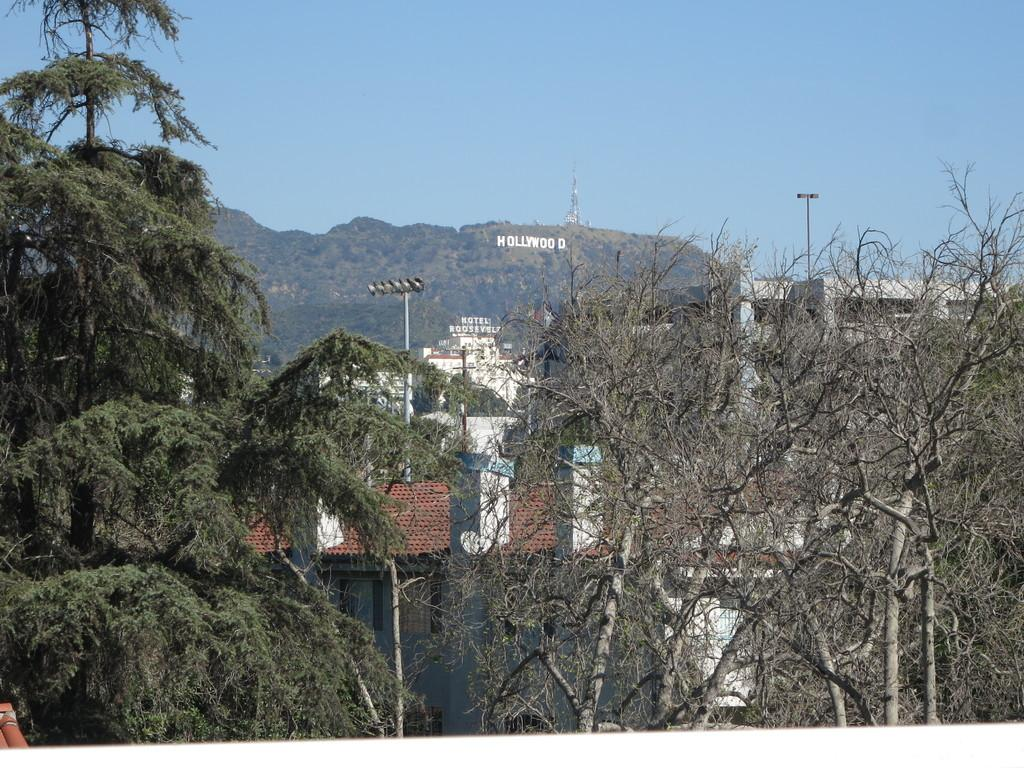What type of natural elements can be seen in the image? There are trees in the image. What type of man-made structures are present in the image? There are buildings in the image. What objects are standing upright in the image? There are two poles in the image. Is there any text visible in the image? Yes, there is text written in the image. What is the condition of the sky in the image? The sky is clear in the image. What type of science experiment is being conducted with the pickle in the image? There is no pickle present in the image, and therefore no such experiment can be observed. Are there any police officers visible in the image? There is no mention of police officers in the provided facts, and they are not visible in the image. 